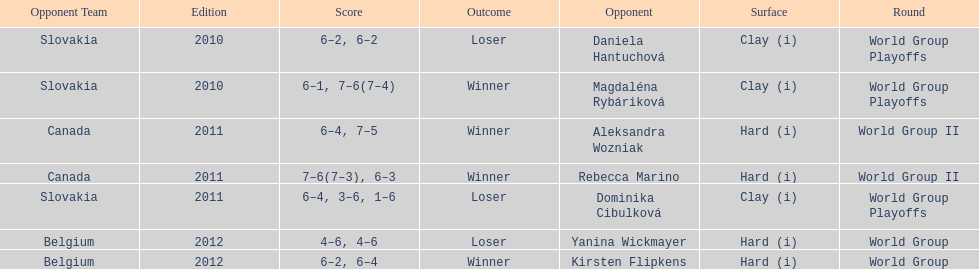What is the other year slovakia played besides 2010? 2011. 